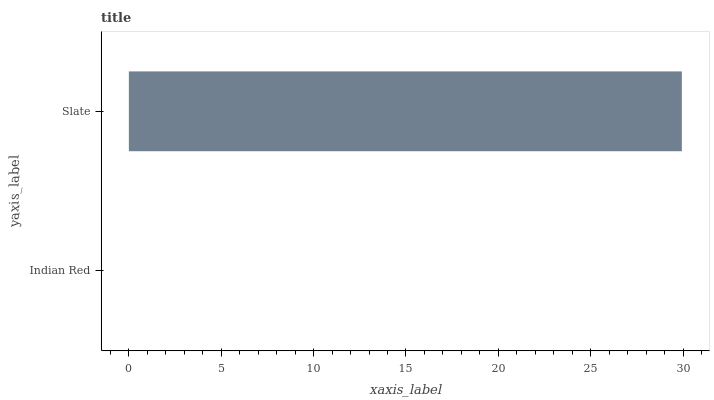Is Indian Red the minimum?
Answer yes or no. Yes. Is Slate the maximum?
Answer yes or no. Yes. Is Slate the minimum?
Answer yes or no. No. Is Slate greater than Indian Red?
Answer yes or no. Yes. Is Indian Red less than Slate?
Answer yes or no. Yes. Is Indian Red greater than Slate?
Answer yes or no. No. Is Slate less than Indian Red?
Answer yes or no. No. Is Slate the high median?
Answer yes or no. Yes. Is Indian Red the low median?
Answer yes or no. Yes. Is Indian Red the high median?
Answer yes or no. No. Is Slate the low median?
Answer yes or no. No. 